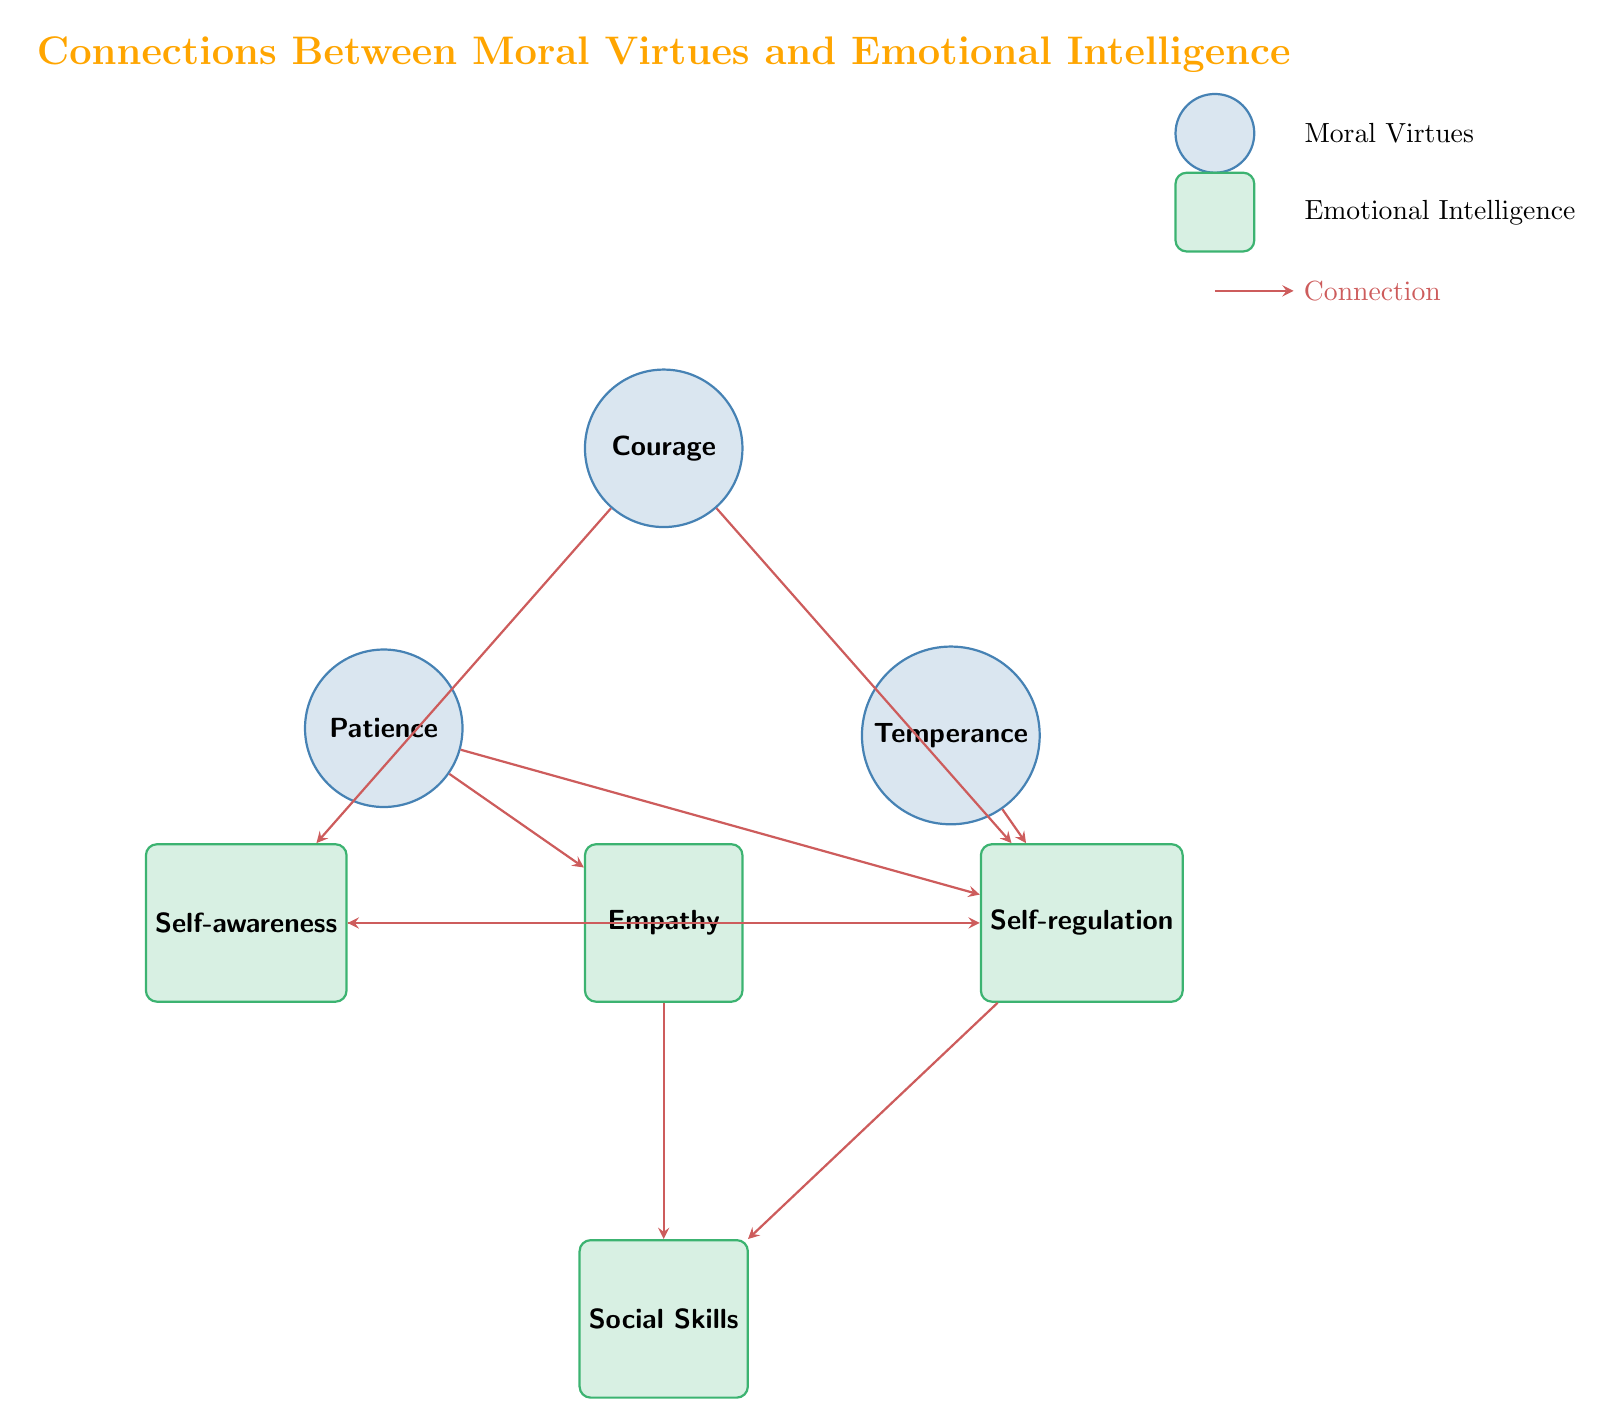What is the total number of nodes in the diagram? The diagram contains a total of 7 nodes, which include three moral virtues (Courage, Temperance, Patience) and four emotional intelligence components (Empathy, Self-awareness, Self-regulation, Social Skills). Counting these together gives the total.
Answer: 7 Which moral virtue connects to Self-awareness? The diagram shows that Courage and Empathy are the two moral virtues that connect to Self-awareness. Therefore, we can directly identify that Courage connects to Self-awareness since it is explicitly listed in the connections.
Answer: Courage How many connections does Empathy have? By examining the diagram, Empathy connects to three other nodes: Self-awareness, Self-regulation, and Social Skills. Counting these connections gives the total number of connections for Empathy.
Answer: 3 What emotional intelligence skill connects with Courage? The connections originating from Courage lead to Self-awareness and Self-regulation. Since both are emotional intelligence skills linked to Courage, we can reference the connections to provide a clear answer.
Answer: Self-awareness, Self-regulation Which emotional intelligence node has the most connections? By analyzing the connections, we see that Empathy connects to Self-awareness and Social Skills, and it has a connection from Patience. Self-regulation has links from Courage, Temperance, Patience, and Self-awareness. Therefore, examining the links reveals Self-regulation has the most at four connections.
Answer: Self-regulation What is the connection between Patience and another emotional intelligence skill? The connections indicate Patience is connected to Empathy and Self-regulation. To identify this clearly, we look for Patience in the diagram and note its direct links.
Answer: Empathy, Self-regulation How many connections are there between moral virtues and emotional intelligence in total? If we count each connection listed in the data, the diagram includes a total of 9 connections between moral virtues and emotional intelligence skills. This sum arises from the individual connections specified.
Answer: 9 Which moral virtue provides a direct link to Self-regulation? The diagram indicates that Courage, Temperance, and Patience connect to Self-regulation. Thus, each of these virtues has a direct connection, but since we're looking for a singular answer, any of the three can be mentioned.
Answer: Courage, Temperance, Patience 